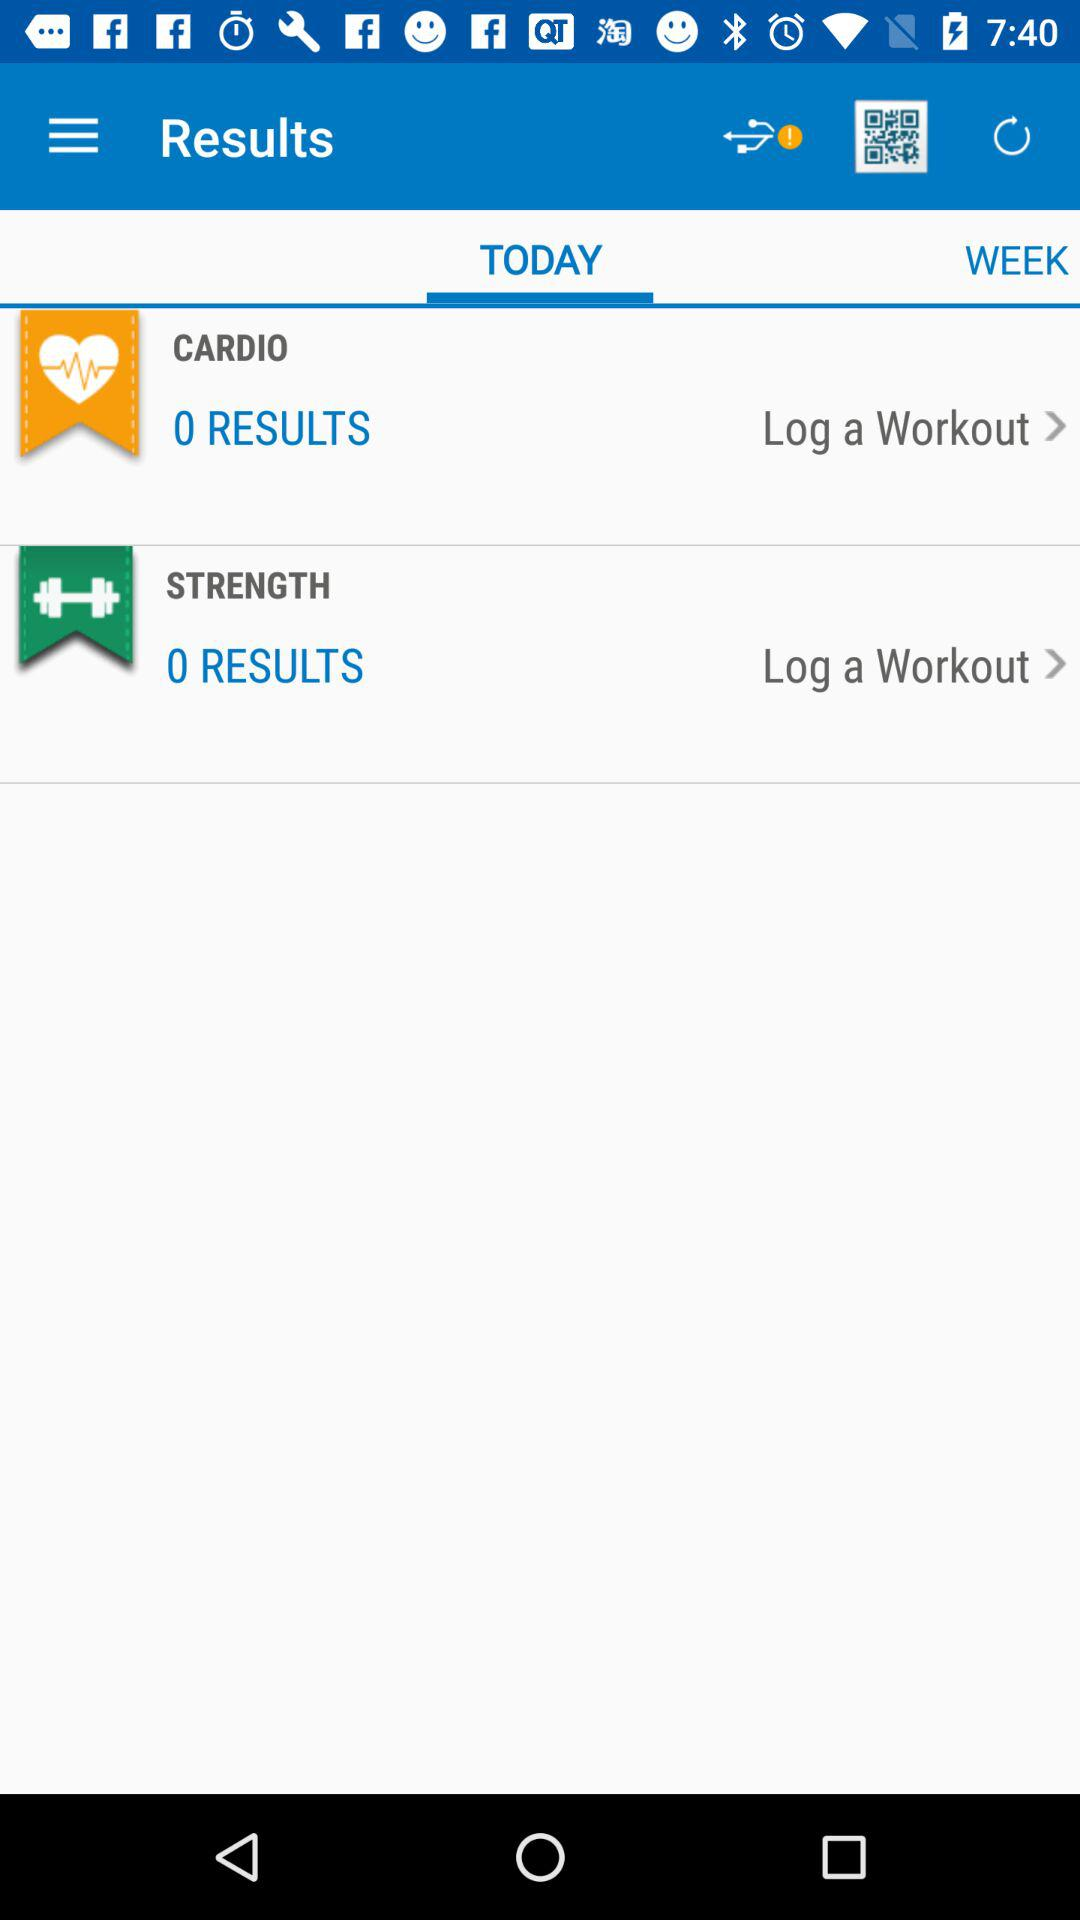Which tab is selected? The selected tab is "TODAY". 